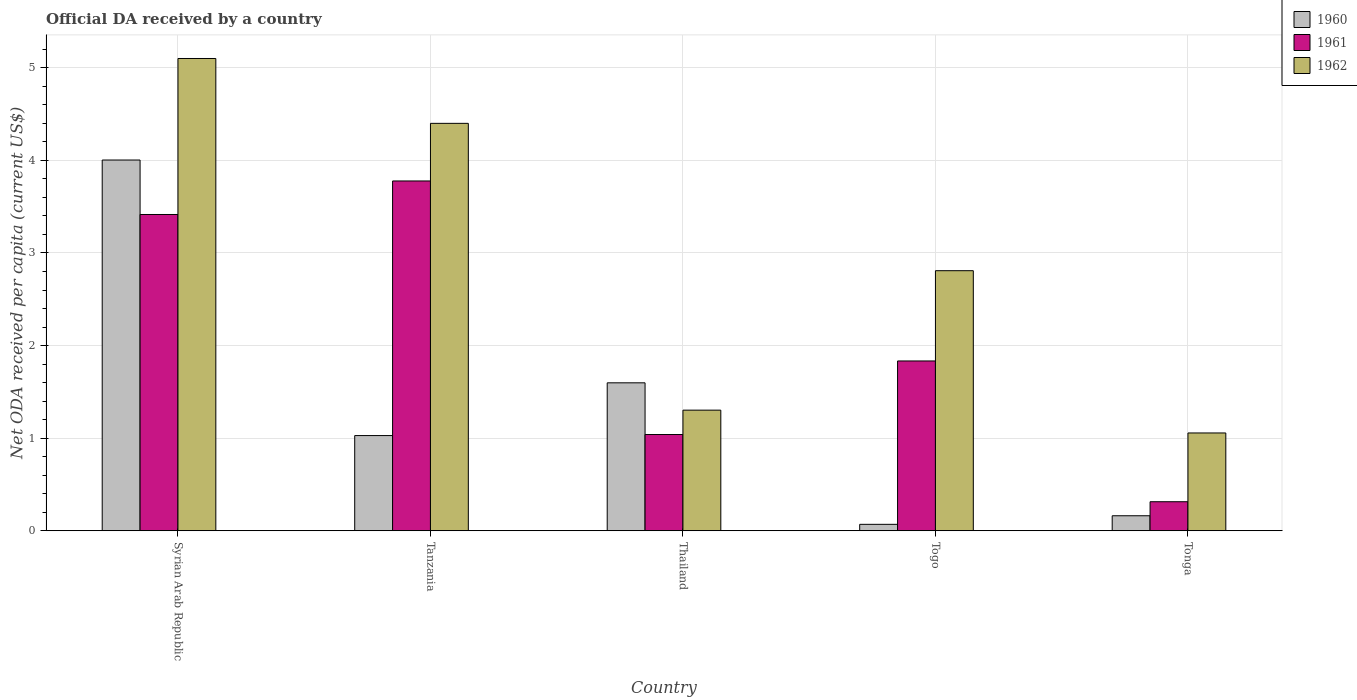How many different coloured bars are there?
Keep it short and to the point. 3. How many groups of bars are there?
Provide a succinct answer. 5. Are the number of bars on each tick of the X-axis equal?
Make the answer very short. Yes. How many bars are there on the 3rd tick from the left?
Your answer should be compact. 3. What is the label of the 3rd group of bars from the left?
Your response must be concise. Thailand. In how many cases, is the number of bars for a given country not equal to the number of legend labels?
Offer a very short reply. 0. What is the ODA received in in 1960 in Togo?
Your answer should be compact. 0.07. Across all countries, what is the maximum ODA received in in 1961?
Ensure brevity in your answer.  3.78. Across all countries, what is the minimum ODA received in in 1960?
Your answer should be very brief. 0.07. In which country was the ODA received in in 1962 maximum?
Give a very brief answer. Syrian Arab Republic. In which country was the ODA received in in 1961 minimum?
Your response must be concise. Tonga. What is the total ODA received in in 1961 in the graph?
Provide a succinct answer. 10.38. What is the difference between the ODA received in in 1960 in Tanzania and that in Tonga?
Offer a terse response. 0.87. What is the difference between the ODA received in in 1960 in Tonga and the ODA received in in 1961 in Thailand?
Give a very brief answer. -0.88. What is the average ODA received in in 1960 per country?
Offer a very short reply. 1.37. What is the difference between the ODA received in of/in 1961 and ODA received in of/in 1960 in Togo?
Offer a terse response. 1.76. What is the ratio of the ODA received in in 1962 in Tanzania to that in Tonga?
Keep it short and to the point. 4.16. Is the ODA received in in 1962 in Tanzania less than that in Togo?
Your response must be concise. No. What is the difference between the highest and the second highest ODA received in in 1961?
Your response must be concise. 1.58. What is the difference between the highest and the lowest ODA received in in 1961?
Your answer should be compact. 3.46. What does the 1st bar from the right in Syrian Arab Republic represents?
Keep it short and to the point. 1962. How many countries are there in the graph?
Your response must be concise. 5. What is the difference between two consecutive major ticks on the Y-axis?
Your answer should be compact. 1. What is the title of the graph?
Your answer should be very brief. Official DA received by a country. What is the label or title of the Y-axis?
Your answer should be very brief. Net ODA received per capita (current US$). What is the Net ODA received per capita (current US$) of 1960 in Syrian Arab Republic?
Offer a terse response. 4. What is the Net ODA received per capita (current US$) in 1961 in Syrian Arab Republic?
Your answer should be very brief. 3.42. What is the Net ODA received per capita (current US$) of 1962 in Syrian Arab Republic?
Provide a short and direct response. 5.1. What is the Net ODA received per capita (current US$) of 1960 in Tanzania?
Provide a short and direct response. 1.03. What is the Net ODA received per capita (current US$) in 1961 in Tanzania?
Your response must be concise. 3.78. What is the Net ODA received per capita (current US$) in 1962 in Tanzania?
Give a very brief answer. 4.4. What is the Net ODA received per capita (current US$) in 1960 in Thailand?
Provide a short and direct response. 1.6. What is the Net ODA received per capita (current US$) in 1961 in Thailand?
Ensure brevity in your answer.  1.04. What is the Net ODA received per capita (current US$) of 1962 in Thailand?
Keep it short and to the point. 1.3. What is the Net ODA received per capita (current US$) in 1960 in Togo?
Your answer should be very brief. 0.07. What is the Net ODA received per capita (current US$) of 1961 in Togo?
Give a very brief answer. 1.83. What is the Net ODA received per capita (current US$) in 1962 in Togo?
Offer a terse response. 2.81. What is the Net ODA received per capita (current US$) in 1960 in Tonga?
Give a very brief answer. 0.16. What is the Net ODA received per capita (current US$) in 1961 in Tonga?
Keep it short and to the point. 0.31. What is the Net ODA received per capita (current US$) of 1962 in Tonga?
Make the answer very short. 1.06. Across all countries, what is the maximum Net ODA received per capita (current US$) in 1960?
Your response must be concise. 4. Across all countries, what is the maximum Net ODA received per capita (current US$) in 1961?
Your answer should be compact. 3.78. Across all countries, what is the maximum Net ODA received per capita (current US$) of 1962?
Provide a short and direct response. 5.1. Across all countries, what is the minimum Net ODA received per capita (current US$) in 1960?
Give a very brief answer. 0.07. Across all countries, what is the minimum Net ODA received per capita (current US$) of 1961?
Keep it short and to the point. 0.31. Across all countries, what is the minimum Net ODA received per capita (current US$) in 1962?
Provide a succinct answer. 1.06. What is the total Net ODA received per capita (current US$) of 1960 in the graph?
Offer a terse response. 6.86. What is the total Net ODA received per capita (current US$) of 1961 in the graph?
Make the answer very short. 10.38. What is the total Net ODA received per capita (current US$) in 1962 in the graph?
Make the answer very short. 14.67. What is the difference between the Net ODA received per capita (current US$) of 1960 in Syrian Arab Republic and that in Tanzania?
Give a very brief answer. 2.98. What is the difference between the Net ODA received per capita (current US$) in 1961 in Syrian Arab Republic and that in Tanzania?
Offer a very short reply. -0.36. What is the difference between the Net ODA received per capita (current US$) in 1962 in Syrian Arab Republic and that in Tanzania?
Your response must be concise. 0.7. What is the difference between the Net ODA received per capita (current US$) in 1960 in Syrian Arab Republic and that in Thailand?
Your answer should be compact. 2.41. What is the difference between the Net ODA received per capita (current US$) of 1961 in Syrian Arab Republic and that in Thailand?
Ensure brevity in your answer.  2.38. What is the difference between the Net ODA received per capita (current US$) in 1962 in Syrian Arab Republic and that in Thailand?
Make the answer very short. 3.8. What is the difference between the Net ODA received per capita (current US$) of 1960 in Syrian Arab Republic and that in Togo?
Provide a short and direct response. 3.93. What is the difference between the Net ODA received per capita (current US$) in 1961 in Syrian Arab Republic and that in Togo?
Give a very brief answer. 1.58. What is the difference between the Net ODA received per capita (current US$) in 1962 in Syrian Arab Republic and that in Togo?
Your answer should be compact. 2.29. What is the difference between the Net ODA received per capita (current US$) of 1960 in Syrian Arab Republic and that in Tonga?
Your response must be concise. 3.84. What is the difference between the Net ODA received per capita (current US$) in 1961 in Syrian Arab Republic and that in Tonga?
Offer a very short reply. 3.1. What is the difference between the Net ODA received per capita (current US$) of 1962 in Syrian Arab Republic and that in Tonga?
Your response must be concise. 4.04. What is the difference between the Net ODA received per capita (current US$) in 1960 in Tanzania and that in Thailand?
Keep it short and to the point. -0.57. What is the difference between the Net ODA received per capita (current US$) in 1961 in Tanzania and that in Thailand?
Your response must be concise. 2.74. What is the difference between the Net ODA received per capita (current US$) of 1962 in Tanzania and that in Thailand?
Make the answer very short. 3.1. What is the difference between the Net ODA received per capita (current US$) of 1960 in Tanzania and that in Togo?
Ensure brevity in your answer.  0.96. What is the difference between the Net ODA received per capita (current US$) in 1961 in Tanzania and that in Togo?
Offer a very short reply. 1.94. What is the difference between the Net ODA received per capita (current US$) in 1962 in Tanzania and that in Togo?
Give a very brief answer. 1.59. What is the difference between the Net ODA received per capita (current US$) of 1960 in Tanzania and that in Tonga?
Offer a very short reply. 0.87. What is the difference between the Net ODA received per capita (current US$) in 1961 in Tanzania and that in Tonga?
Your answer should be very brief. 3.46. What is the difference between the Net ODA received per capita (current US$) in 1962 in Tanzania and that in Tonga?
Provide a succinct answer. 3.34. What is the difference between the Net ODA received per capita (current US$) of 1960 in Thailand and that in Togo?
Your answer should be very brief. 1.53. What is the difference between the Net ODA received per capita (current US$) in 1961 in Thailand and that in Togo?
Make the answer very short. -0.79. What is the difference between the Net ODA received per capita (current US$) in 1962 in Thailand and that in Togo?
Keep it short and to the point. -1.51. What is the difference between the Net ODA received per capita (current US$) of 1960 in Thailand and that in Tonga?
Your answer should be compact. 1.44. What is the difference between the Net ODA received per capita (current US$) in 1961 in Thailand and that in Tonga?
Your response must be concise. 0.73. What is the difference between the Net ODA received per capita (current US$) in 1962 in Thailand and that in Tonga?
Make the answer very short. 0.25. What is the difference between the Net ODA received per capita (current US$) of 1960 in Togo and that in Tonga?
Make the answer very short. -0.09. What is the difference between the Net ODA received per capita (current US$) of 1961 in Togo and that in Tonga?
Make the answer very short. 1.52. What is the difference between the Net ODA received per capita (current US$) of 1962 in Togo and that in Tonga?
Your answer should be very brief. 1.75. What is the difference between the Net ODA received per capita (current US$) of 1960 in Syrian Arab Republic and the Net ODA received per capita (current US$) of 1961 in Tanzania?
Ensure brevity in your answer.  0.23. What is the difference between the Net ODA received per capita (current US$) in 1960 in Syrian Arab Republic and the Net ODA received per capita (current US$) in 1962 in Tanzania?
Provide a succinct answer. -0.4. What is the difference between the Net ODA received per capita (current US$) in 1961 in Syrian Arab Republic and the Net ODA received per capita (current US$) in 1962 in Tanzania?
Give a very brief answer. -0.98. What is the difference between the Net ODA received per capita (current US$) in 1960 in Syrian Arab Republic and the Net ODA received per capita (current US$) in 1961 in Thailand?
Make the answer very short. 2.96. What is the difference between the Net ODA received per capita (current US$) of 1960 in Syrian Arab Republic and the Net ODA received per capita (current US$) of 1962 in Thailand?
Give a very brief answer. 2.7. What is the difference between the Net ODA received per capita (current US$) of 1961 in Syrian Arab Republic and the Net ODA received per capita (current US$) of 1962 in Thailand?
Offer a very short reply. 2.11. What is the difference between the Net ODA received per capita (current US$) of 1960 in Syrian Arab Republic and the Net ODA received per capita (current US$) of 1961 in Togo?
Give a very brief answer. 2.17. What is the difference between the Net ODA received per capita (current US$) in 1960 in Syrian Arab Republic and the Net ODA received per capita (current US$) in 1962 in Togo?
Offer a very short reply. 1.2. What is the difference between the Net ODA received per capita (current US$) of 1961 in Syrian Arab Republic and the Net ODA received per capita (current US$) of 1962 in Togo?
Your response must be concise. 0.61. What is the difference between the Net ODA received per capita (current US$) of 1960 in Syrian Arab Republic and the Net ODA received per capita (current US$) of 1961 in Tonga?
Provide a succinct answer. 3.69. What is the difference between the Net ODA received per capita (current US$) in 1960 in Syrian Arab Republic and the Net ODA received per capita (current US$) in 1962 in Tonga?
Provide a short and direct response. 2.95. What is the difference between the Net ODA received per capita (current US$) of 1961 in Syrian Arab Republic and the Net ODA received per capita (current US$) of 1962 in Tonga?
Your response must be concise. 2.36. What is the difference between the Net ODA received per capita (current US$) in 1960 in Tanzania and the Net ODA received per capita (current US$) in 1961 in Thailand?
Provide a short and direct response. -0.01. What is the difference between the Net ODA received per capita (current US$) of 1960 in Tanzania and the Net ODA received per capita (current US$) of 1962 in Thailand?
Your answer should be compact. -0.27. What is the difference between the Net ODA received per capita (current US$) in 1961 in Tanzania and the Net ODA received per capita (current US$) in 1962 in Thailand?
Make the answer very short. 2.48. What is the difference between the Net ODA received per capita (current US$) in 1960 in Tanzania and the Net ODA received per capita (current US$) in 1961 in Togo?
Make the answer very short. -0.81. What is the difference between the Net ODA received per capita (current US$) in 1960 in Tanzania and the Net ODA received per capita (current US$) in 1962 in Togo?
Offer a very short reply. -1.78. What is the difference between the Net ODA received per capita (current US$) of 1961 in Tanzania and the Net ODA received per capita (current US$) of 1962 in Togo?
Make the answer very short. 0.97. What is the difference between the Net ODA received per capita (current US$) in 1960 in Tanzania and the Net ODA received per capita (current US$) in 1961 in Tonga?
Keep it short and to the point. 0.71. What is the difference between the Net ODA received per capita (current US$) of 1960 in Tanzania and the Net ODA received per capita (current US$) of 1962 in Tonga?
Make the answer very short. -0.03. What is the difference between the Net ODA received per capita (current US$) of 1961 in Tanzania and the Net ODA received per capita (current US$) of 1962 in Tonga?
Offer a very short reply. 2.72. What is the difference between the Net ODA received per capita (current US$) in 1960 in Thailand and the Net ODA received per capita (current US$) in 1961 in Togo?
Provide a short and direct response. -0.24. What is the difference between the Net ODA received per capita (current US$) of 1960 in Thailand and the Net ODA received per capita (current US$) of 1962 in Togo?
Ensure brevity in your answer.  -1.21. What is the difference between the Net ODA received per capita (current US$) of 1961 in Thailand and the Net ODA received per capita (current US$) of 1962 in Togo?
Your answer should be compact. -1.77. What is the difference between the Net ODA received per capita (current US$) of 1960 in Thailand and the Net ODA received per capita (current US$) of 1961 in Tonga?
Give a very brief answer. 1.28. What is the difference between the Net ODA received per capita (current US$) of 1960 in Thailand and the Net ODA received per capita (current US$) of 1962 in Tonga?
Provide a succinct answer. 0.54. What is the difference between the Net ODA received per capita (current US$) in 1961 in Thailand and the Net ODA received per capita (current US$) in 1962 in Tonga?
Make the answer very short. -0.02. What is the difference between the Net ODA received per capita (current US$) of 1960 in Togo and the Net ODA received per capita (current US$) of 1961 in Tonga?
Offer a very short reply. -0.24. What is the difference between the Net ODA received per capita (current US$) in 1960 in Togo and the Net ODA received per capita (current US$) in 1962 in Tonga?
Offer a very short reply. -0.99. What is the difference between the Net ODA received per capita (current US$) in 1961 in Togo and the Net ODA received per capita (current US$) in 1962 in Tonga?
Your response must be concise. 0.78. What is the average Net ODA received per capita (current US$) of 1960 per country?
Your response must be concise. 1.37. What is the average Net ODA received per capita (current US$) of 1961 per country?
Ensure brevity in your answer.  2.08. What is the average Net ODA received per capita (current US$) in 1962 per country?
Offer a very short reply. 2.93. What is the difference between the Net ODA received per capita (current US$) in 1960 and Net ODA received per capita (current US$) in 1961 in Syrian Arab Republic?
Offer a terse response. 0.59. What is the difference between the Net ODA received per capita (current US$) in 1960 and Net ODA received per capita (current US$) in 1962 in Syrian Arab Republic?
Give a very brief answer. -1.1. What is the difference between the Net ODA received per capita (current US$) in 1961 and Net ODA received per capita (current US$) in 1962 in Syrian Arab Republic?
Keep it short and to the point. -1.68. What is the difference between the Net ODA received per capita (current US$) in 1960 and Net ODA received per capita (current US$) in 1961 in Tanzania?
Keep it short and to the point. -2.75. What is the difference between the Net ODA received per capita (current US$) in 1960 and Net ODA received per capita (current US$) in 1962 in Tanzania?
Your answer should be very brief. -3.37. What is the difference between the Net ODA received per capita (current US$) of 1961 and Net ODA received per capita (current US$) of 1962 in Tanzania?
Make the answer very short. -0.62. What is the difference between the Net ODA received per capita (current US$) in 1960 and Net ODA received per capita (current US$) in 1961 in Thailand?
Your answer should be compact. 0.56. What is the difference between the Net ODA received per capita (current US$) of 1960 and Net ODA received per capita (current US$) of 1962 in Thailand?
Make the answer very short. 0.3. What is the difference between the Net ODA received per capita (current US$) of 1961 and Net ODA received per capita (current US$) of 1962 in Thailand?
Provide a succinct answer. -0.26. What is the difference between the Net ODA received per capita (current US$) of 1960 and Net ODA received per capita (current US$) of 1961 in Togo?
Keep it short and to the point. -1.76. What is the difference between the Net ODA received per capita (current US$) in 1960 and Net ODA received per capita (current US$) in 1962 in Togo?
Provide a short and direct response. -2.74. What is the difference between the Net ODA received per capita (current US$) in 1961 and Net ODA received per capita (current US$) in 1962 in Togo?
Ensure brevity in your answer.  -0.97. What is the difference between the Net ODA received per capita (current US$) of 1960 and Net ODA received per capita (current US$) of 1961 in Tonga?
Make the answer very short. -0.15. What is the difference between the Net ODA received per capita (current US$) in 1960 and Net ODA received per capita (current US$) in 1962 in Tonga?
Make the answer very short. -0.89. What is the difference between the Net ODA received per capita (current US$) of 1961 and Net ODA received per capita (current US$) of 1962 in Tonga?
Give a very brief answer. -0.74. What is the ratio of the Net ODA received per capita (current US$) in 1960 in Syrian Arab Republic to that in Tanzania?
Offer a terse response. 3.89. What is the ratio of the Net ODA received per capita (current US$) of 1961 in Syrian Arab Republic to that in Tanzania?
Make the answer very short. 0.9. What is the ratio of the Net ODA received per capita (current US$) of 1962 in Syrian Arab Republic to that in Tanzania?
Your answer should be compact. 1.16. What is the ratio of the Net ODA received per capita (current US$) of 1960 in Syrian Arab Republic to that in Thailand?
Provide a succinct answer. 2.51. What is the ratio of the Net ODA received per capita (current US$) in 1961 in Syrian Arab Republic to that in Thailand?
Provide a short and direct response. 3.29. What is the ratio of the Net ODA received per capita (current US$) of 1962 in Syrian Arab Republic to that in Thailand?
Make the answer very short. 3.91. What is the ratio of the Net ODA received per capita (current US$) of 1960 in Syrian Arab Republic to that in Togo?
Ensure brevity in your answer.  57.53. What is the ratio of the Net ODA received per capita (current US$) in 1961 in Syrian Arab Republic to that in Togo?
Your response must be concise. 1.86. What is the ratio of the Net ODA received per capita (current US$) in 1962 in Syrian Arab Republic to that in Togo?
Provide a short and direct response. 1.82. What is the ratio of the Net ODA received per capita (current US$) of 1960 in Syrian Arab Republic to that in Tonga?
Provide a short and direct response. 24.67. What is the ratio of the Net ODA received per capita (current US$) in 1961 in Syrian Arab Republic to that in Tonga?
Ensure brevity in your answer.  10.89. What is the ratio of the Net ODA received per capita (current US$) in 1962 in Syrian Arab Republic to that in Tonga?
Keep it short and to the point. 4.83. What is the ratio of the Net ODA received per capita (current US$) of 1960 in Tanzania to that in Thailand?
Keep it short and to the point. 0.64. What is the ratio of the Net ODA received per capita (current US$) in 1961 in Tanzania to that in Thailand?
Provide a short and direct response. 3.63. What is the ratio of the Net ODA received per capita (current US$) of 1962 in Tanzania to that in Thailand?
Your answer should be compact. 3.38. What is the ratio of the Net ODA received per capita (current US$) of 1960 in Tanzania to that in Togo?
Provide a short and direct response. 14.78. What is the ratio of the Net ODA received per capita (current US$) of 1961 in Tanzania to that in Togo?
Keep it short and to the point. 2.06. What is the ratio of the Net ODA received per capita (current US$) of 1962 in Tanzania to that in Togo?
Your answer should be compact. 1.57. What is the ratio of the Net ODA received per capita (current US$) of 1960 in Tanzania to that in Tonga?
Your answer should be compact. 6.33. What is the ratio of the Net ODA received per capita (current US$) of 1961 in Tanzania to that in Tonga?
Provide a short and direct response. 12.04. What is the ratio of the Net ODA received per capita (current US$) of 1962 in Tanzania to that in Tonga?
Your answer should be compact. 4.16. What is the ratio of the Net ODA received per capita (current US$) in 1960 in Thailand to that in Togo?
Ensure brevity in your answer.  22.96. What is the ratio of the Net ODA received per capita (current US$) in 1961 in Thailand to that in Togo?
Provide a succinct answer. 0.57. What is the ratio of the Net ODA received per capita (current US$) in 1962 in Thailand to that in Togo?
Ensure brevity in your answer.  0.46. What is the ratio of the Net ODA received per capita (current US$) in 1960 in Thailand to that in Tonga?
Your answer should be compact. 9.84. What is the ratio of the Net ODA received per capita (current US$) of 1961 in Thailand to that in Tonga?
Your answer should be very brief. 3.31. What is the ratio of the Net ODA received per capita (current US$) of 1962 in Thailand to that in Tonga?
Your answer should be very brief. 1.23. What is the ratio of the Net ODA received per capita (current US$) in 1960 in Togo to that in Tonga?
Provide a short and direct response. 0.43. What is the ratio of the Net ODA received per capita (current US$) of 1961 in Togo to that in Tonga?
Provide a succinct answer. 5.85. What is the ratio of the Net ODA received per capita (current US$) in 1962 in Togo to that in Tonga?
Provide a short and direct response. 2.66. What is the difference between the highest and the second highest Net ODA received per capita (current US$) of 1960?
Your answer should be very brief. 2.41. What is the difference between the highest and the second highest Net ODA received per capita (current US$) in 1961?
Give a very brief answer. 0.36. What is the difference between the highest and the second highest Net ODA received per capita (current US$) of 1962?
Ensure brevity in your answer.  0.7. What is the difference between the highest and the lowest Net ODA received per capita (current US$) in 1960?
Make the answer very short. 3.93. What is the difference between the highest and the lowest Net ODA received per capita (current US$) of 1961?
Provide a short and direct response. 3.46. What is the difference between the highest and the lowest Net ODA received per capita (current US$) in 1962?
Ensure brevity in your answer.  4.04. 